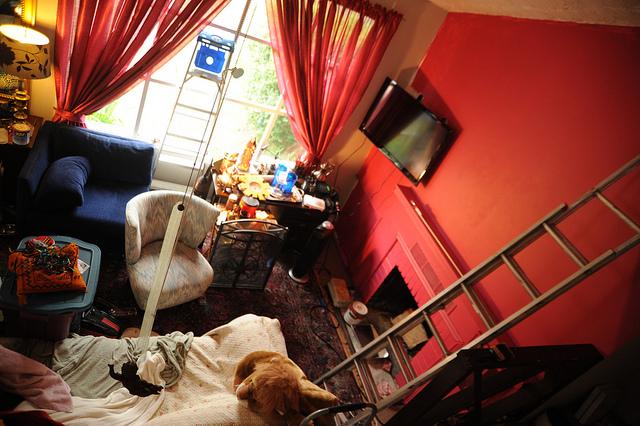Is the nearest ladder extendable?
Answer briefly. Yes. Is the TV on?
Quick response, please. No. What color are the walls?
Be succinct. Red. How many ladders are there?
Give a very brief answer. 2. 